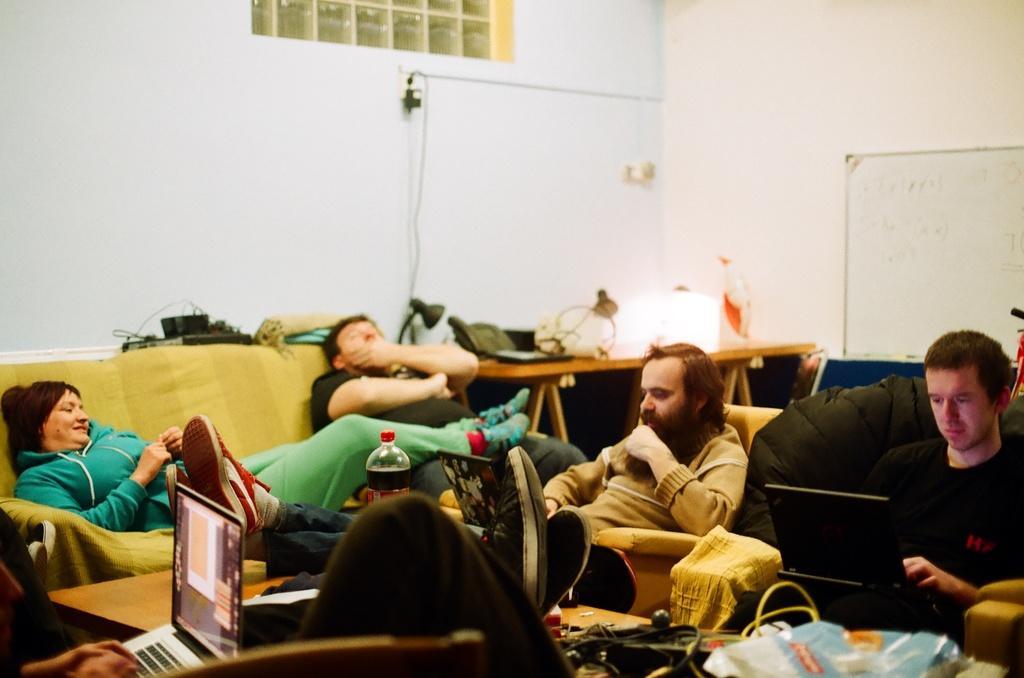Describe this image in one or two sentences. In this image, we can see a group of people are sitting. Here we can see laptops, table, some objects. Background we can see a board, wall, few things. 